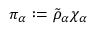<formula> <loc_0><loc_0><loc_500><loc_500>\pi _ { \alpha } \colon = \tilde { \rho } _ { \alpha } \chi _ { \alpha }</formula> 